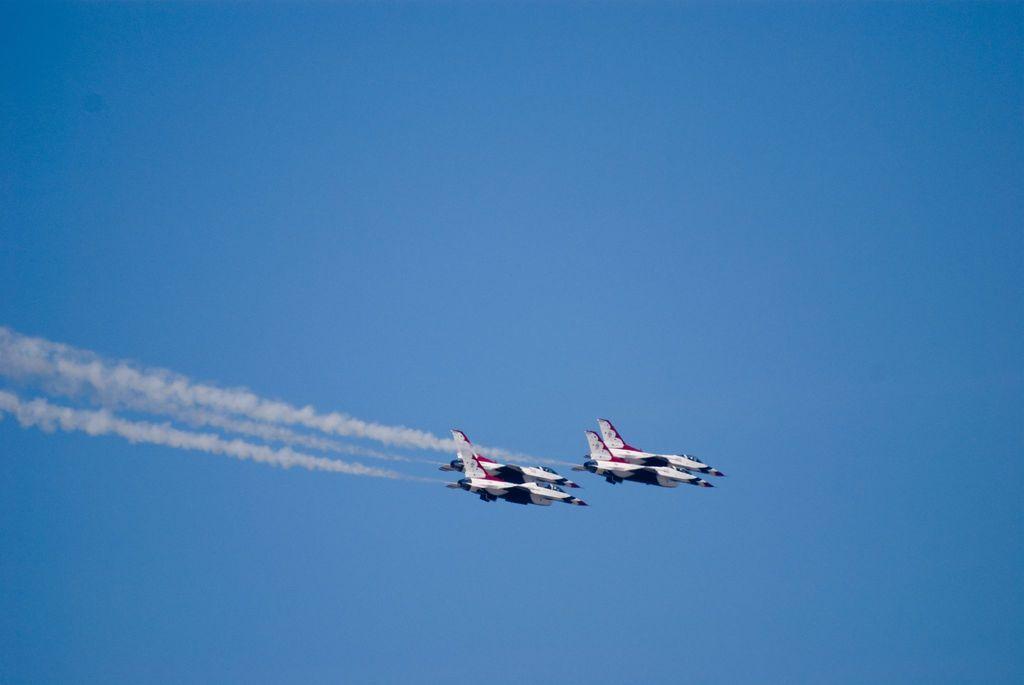Could you give a brief overview of what you see in this image? In the middle of the image I can see jets are flying in the air. Smoke is coming out from the jets. In the background of the image there is sky.   